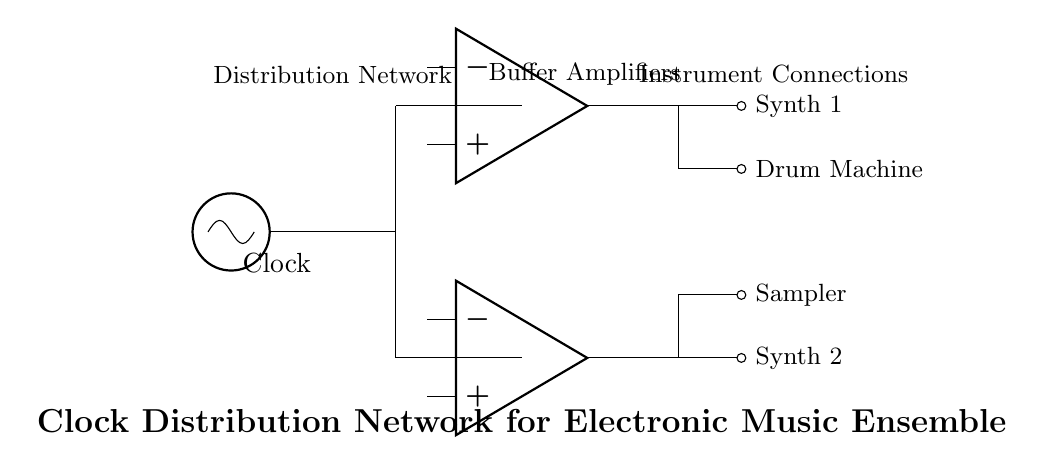What is the main component generating the clock signal? The main component generating the clock signal is the oscillator, which is depicted at the beginning of the circuit.
Answer: oscillator How many buffer amplifiers are used in the distribution network? There are two buffer amplifiers in the distribution network as shown by the two op amps connected to the clock distribution paths.
Answer: two What instruments are connected to the output of the first buffer amplifier? The instruments connected to the output of the first buffer amplifier are Synth 1 and the Drum Machine, which are indicated in the connections stemming from the first op amp.
Answer: Synth 1 and Drum Machine What is the purpose of the buffer amplifiers in this circuit? Buffer amplifiers are used to isolate the clock signal and help maintain signal integrity when distributing the clock to multiple connected instruments.
Answer: isolation and signal integrity Which component is responsible for driving Synth 2? Synth 2 is driven directly by the second buffer amplifier, as indicated by its connection to the output of the second op amp.
Answer: second buffer amplifier How many instrument connections are shown in the circuit diagram? There are four instrument connections shown in the circuit, which includes two synths, a drum machine, and a sampler.
Answer: four 